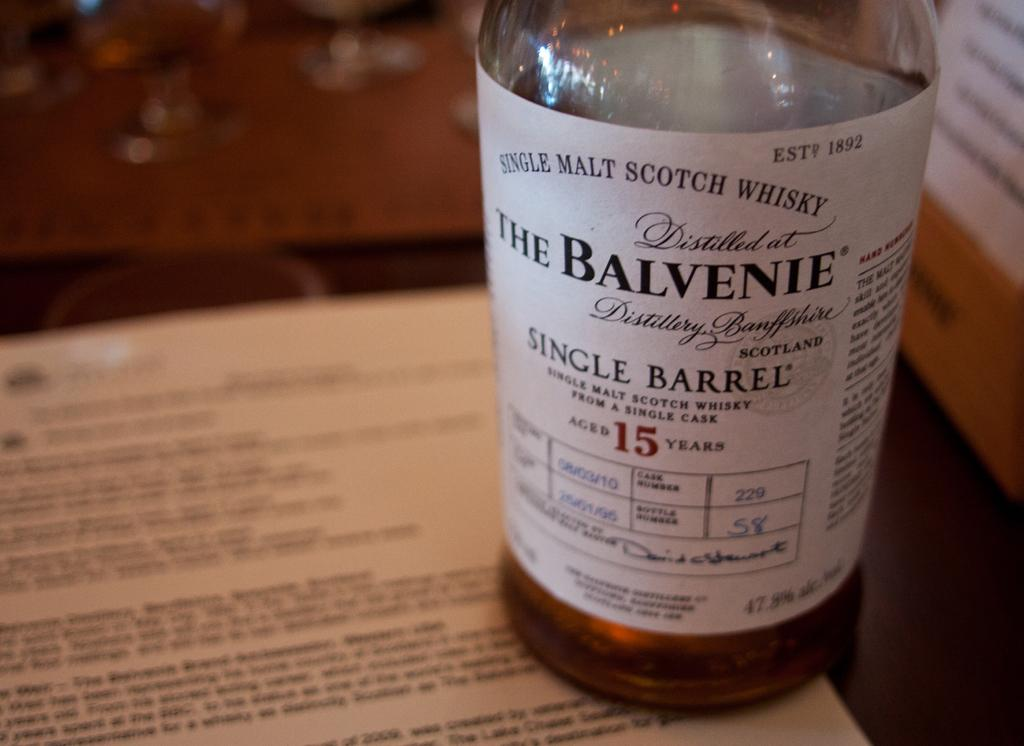What piece of furniture is present in the image? There is a table in the image. What is placed on the table? There is a paper and glasses on the table. What else can be seen on the table? There is a bottle with liquid on the table. Can you describe the bottle further? The bottle has a sticker attached to it. How many women are balancing on the table in the image? There are no women present in the image, and therefore no one is balancing on the table. Can you see any mice running around on the table in the image? There are no mice present in the image; the table only contains a paper, glasses, a bottle, and a sticker. 